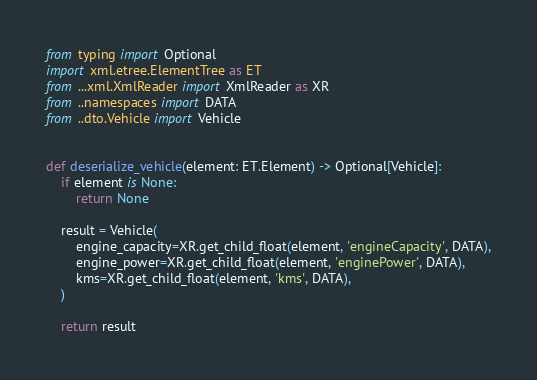Convert code to text. <code><loc_0><loc_0><loc_500><loc_500><_Python_>from typing import Optional
import xml.etree.ElementTree as ET
from ...xml.XmlReader import XmlReader as XR
from ..namespaces import DATA
from ..dto.Vehicle import Vehicle


def deserialize_vehicle(element: ET.Element) -> Optional[Vehicle]:
    if element is None:
        return None

    result = Vehicle(
        engine_capacity=XR.get_child_float(element, 'engineCapacity', DATA),
        engine_power=XR.get_child_float(element, 'enginePower', DATA),
        kms=XR.get_child_float(element, 'kms', DATA),
    )

    return result
</code> 